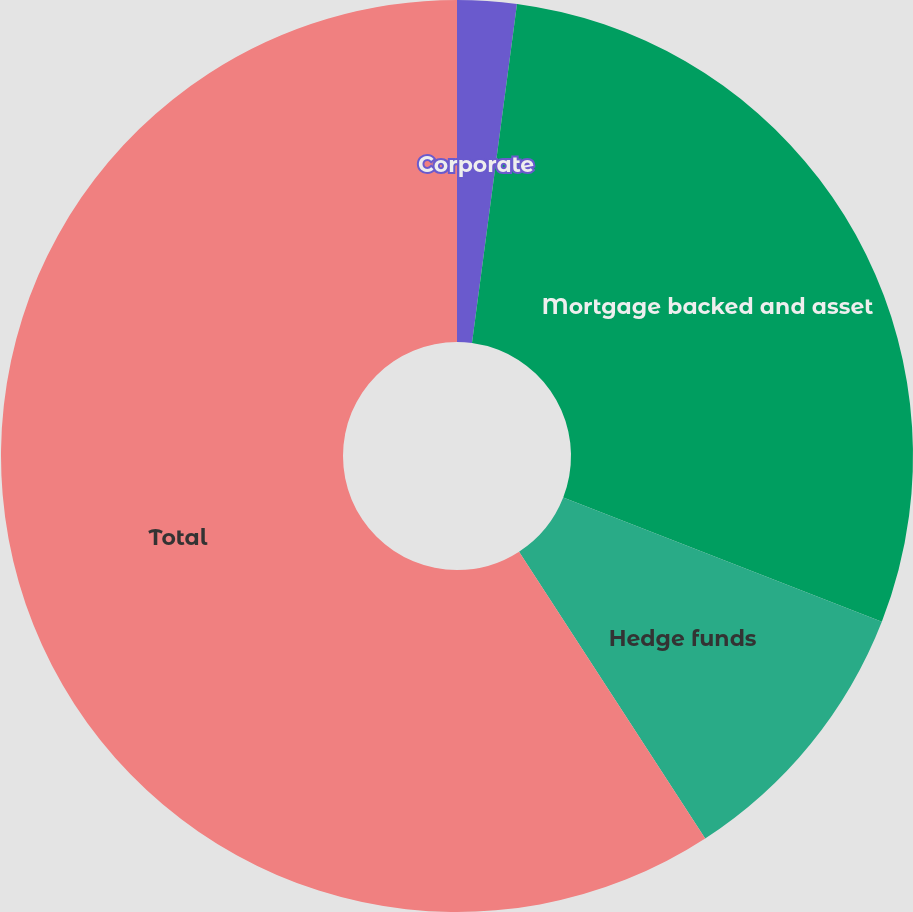<chart> <loc_0><loc_0><loc_500><loc_500><pie_chart><fcel>Corporate<fcel>Mortgage backed and asset<fcel>Hedge funds<fcel>Total<nl><fcel>2.1%<fcel>28.82%<fcel>9.92%<fcel>59.16%<nl></chart> 